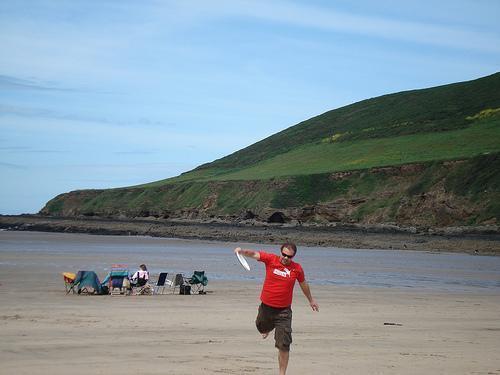How many chairs are visible?
Give a very brief answer. 7. 